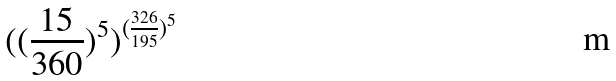Convert formula to latex. <formula><loc_0><loc_0><loc_500><loc_500>( ( \frac { 1 5 } { 3 6 0 } ) ^ { 5 } ) ^ { ( \frac { 3 2 6 } { 1 9 5 } ) ^ { 5 } }</formula> 